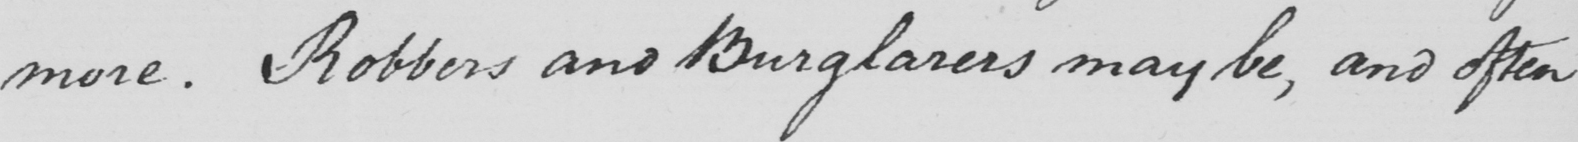Transcribe the text shown in this historical manuscript line. more . Robbers and Burglarers may be , and often 